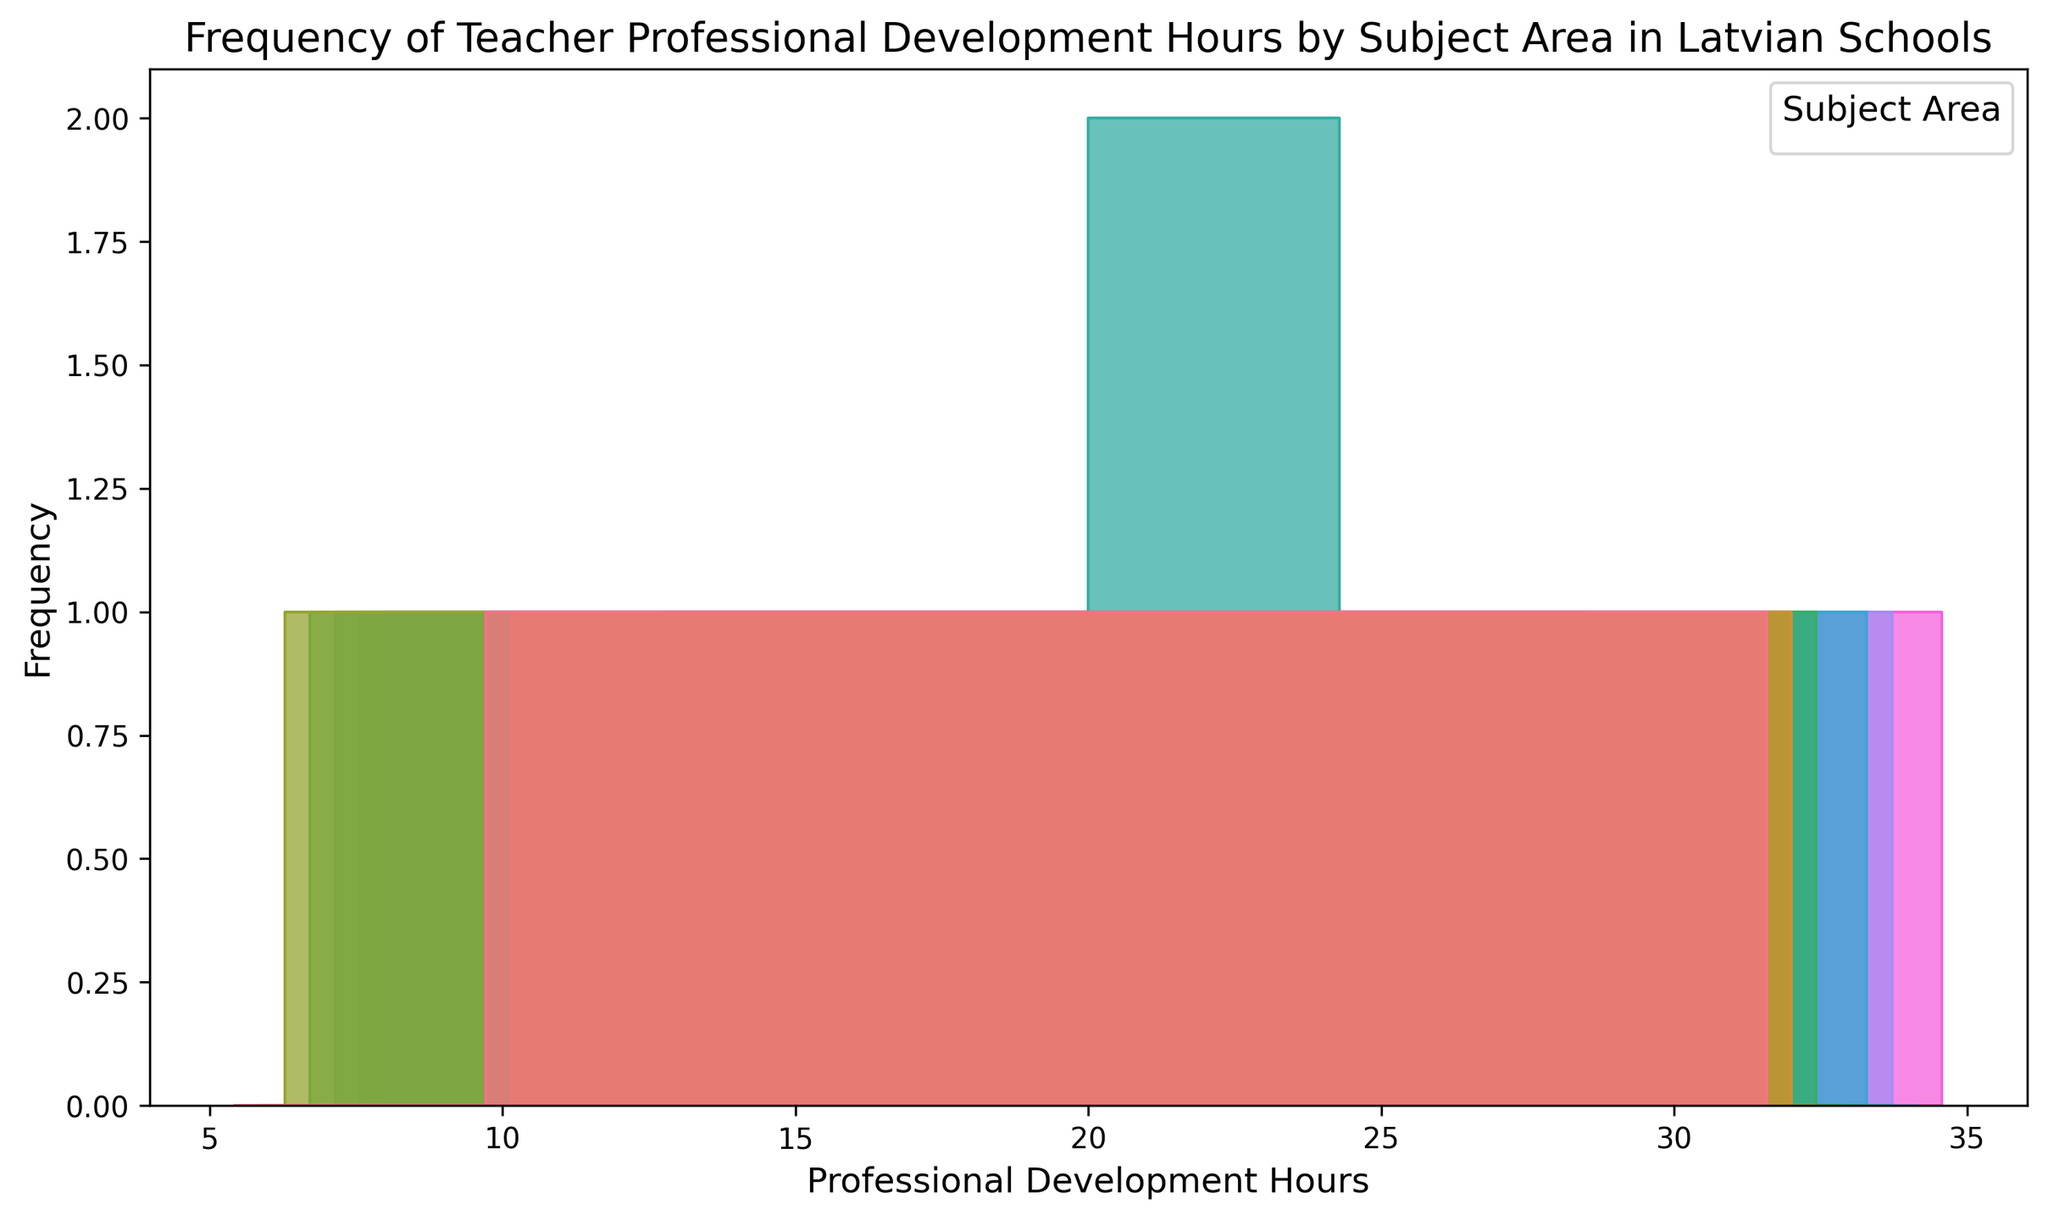What's the most frequently occurring range of professional development hours for Mathematics? To determine the most frequently occurring range of hours for Mathematics, look at the histogram and check which bar is the highest for Mathematics (assumed to have a distinct color or pattern). The highest bar indicates the range with the most counts.
Answer: 30-35 hours Which subject area has the highest maximum range of professional development hours? To find the subject area with the highest maximum range, examine the furthest right bar for each subject. Identify which subject has a bar at the highest hour range.
Answer: Mathematics and Technology Is there a subject area where the professional development hours distribution is evenly spread out? To determine if any subject area has an even spread, look at the bars corresponding to that subject and check if they have roughly equal heights across different hours. This means no single hour category dominates in counts.
Answer: Language and Social Studies (to some extent) How do the professional development hours for Physical Education compare to that of Arts across the lower ranges (0-15 hours)? For comparison, observe the height of the bars for Physical Education and Arts in the 0-15 hour range. Compare the relative heights to determine which has more or fewer hours in each range.
Answer: Physical Education generally has fewer hours than Arts in the 0-15 hour range What's the average of the ranges of professional development hours for History? To calculate the average, add up all the midpoints of the histogram bar ranges for History and divide by the number of ranges. The midpoints are (5+10)/2, (10+15)/2, etc., then sum these up and divide by the number of ranges.
Answer: 17.5 hours Which subject area shows the greatest spread in professional development hours? The greatest spread is indicated by the difference from the lowest to highest professional development hours per subject area. Identify the minimum and maximum ranges for each subject, then calculate the spreads and compare.
Answer: Mathematics and Technology (both range from 10-35 hours) What’s the sum of frequencies of professional development hours for Science between 10 and 25 hours? Look at the histogram bars for Science within 10-25 hours, then add the frequencies/counts of these bars together.
Answer: Sum of frequencies for Science between 10-25 hours Which subjects have professional development hours peaking in the 20-25 hour range? Check the histogram bars for the 20-25 hour range and see which subjects have the highest bars or peaks within this range.
Answer: Science, Mathematics, and Technology How frequently do teachers have exactly 10 hours of professional development in Science? Focus on the bar representing 10 hours for Science and note the height or count of this specific bar.
Answer: Frequent (exact count visible in the histogram) Do any subjects have fewer than 10 hours of professional development? Examine if there are bars left of the 10-hour mark, corresponding to any subject on the histogram.
Answer: History, Physical Education, and Arts 